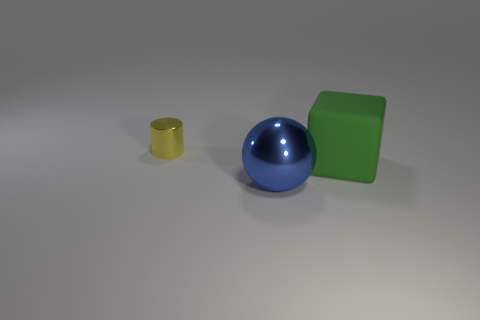Add 2 large shiny things. How many objects exist? 5 Subtract all spheres. How many objects are left? 2 Subtract all big green rubber things. Subtract all tiny cylinders. How many objects are left? 1 Add 2 big green rubber cubes. How many big green rubber cubes are left? 3 Add 3 cyan rubber spheres. How many cyan rubber spheres exist? 3 Subtract 0 red balls. How many objects are left? 3 